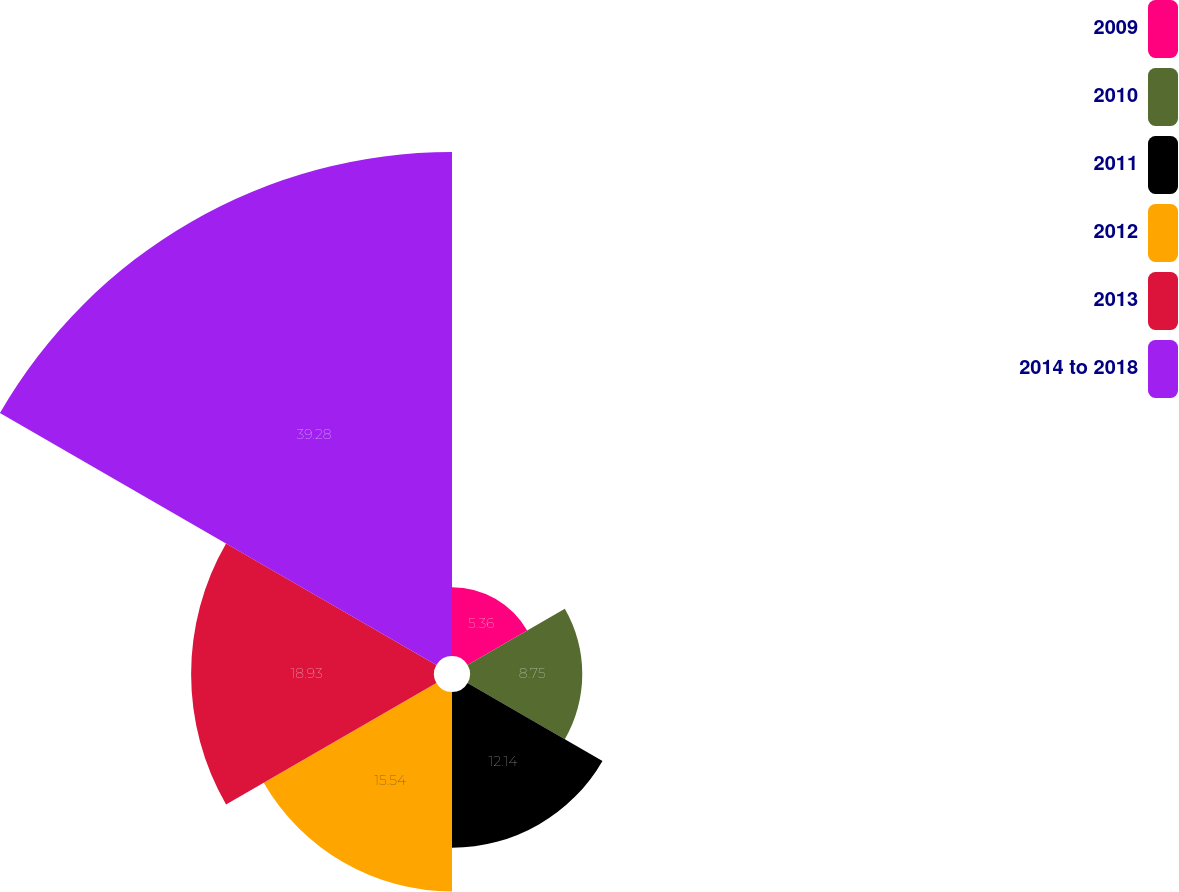<chart> <loc_0><loc_0><loc_500><loc_500><pie_chart><fcel>2009<fcel>2010<fcel>2011<fcel>2012<fcel>2013<fcel>2014 to 2018<nl><fcel>5.36%<fcel>8.75%<fcel>12.14%<fcel>15.54%<fcel>18.93%<fcel>39.28%<nl></chart> 